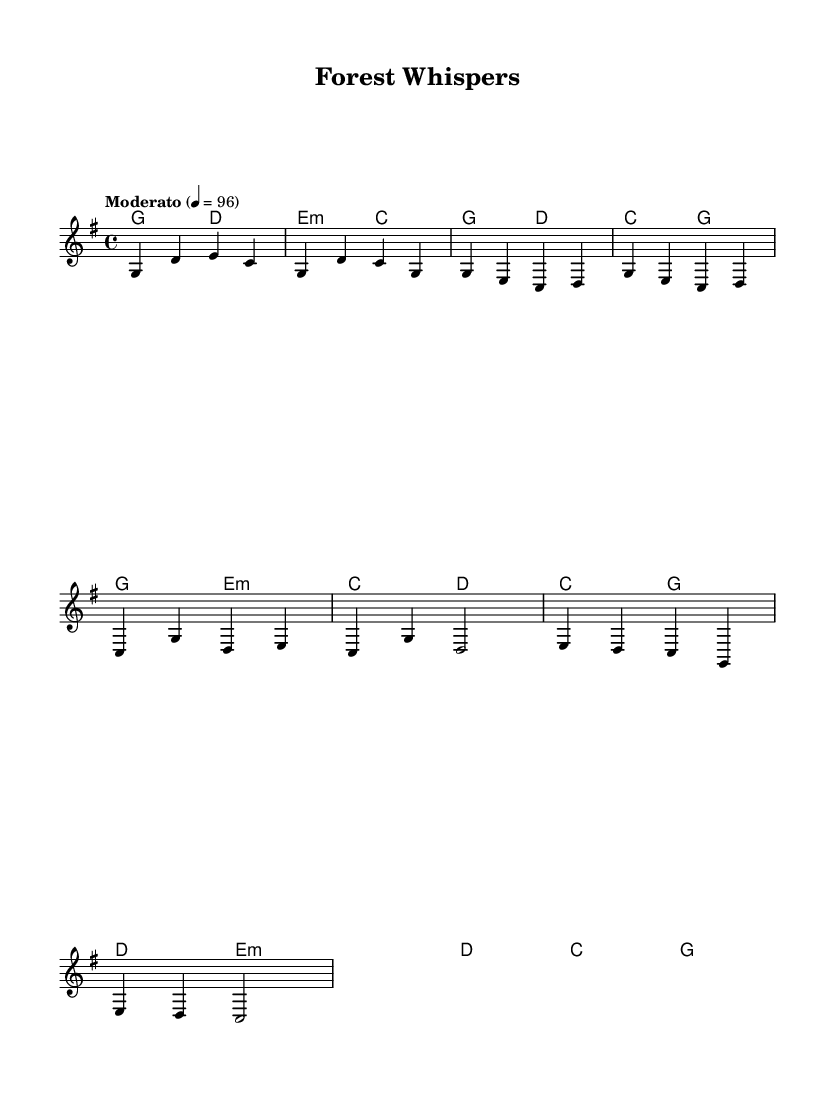What is the key signature of this music? The key signature is G major, which has one sharp (F#). This can be determined by looking at the key signature indicated at the beginning of the score.
Answer: G major What is the time signature of this music? The time signature is 4/4, meaning there are four beats in each measure and the quarter note receives one beat. The time signature is clearly marked at the start of the score.
Answer: 4/4 What is the tempo marking for this piece? The tempo marking is "Moderato," which indicates a moderate speed for the piece. This is stated at the beginning where the tempo is specified along with the metronome marking of 96 beats per minute.
Answer: Moderato How many measures are present in the intro section? The intro section contains 4 measures, which can be counted by reviewing the notated music in the specified section marked as the intro.
Answer: 4 What is the chord used in the first measure? The chord used in the first measure is G major, which can be identified by looking at the chord notation at the beginning of the score.
Answer: G Which section features a bridge? The bridge section is indicated as a transition in the piece, and it can be found after the verse and chorus sections. It is identified by the word "Bridge" in the header or organization of the music.
Answer: Bridge What is the last chord noted in the score? The last chord noted in the score is G major, which is the final chord in the given score after the bridge section. This can be confirmed by checking the chord progressions towards the end of the score.
Answer: G 